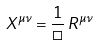Convert formula to latex. <formula><loc_0><loc_0><loc_500><loc_500>X ^ { \mu \nu } = \frac { 1 } { \Box } \, R ^ { \mu \nu }</formula> 